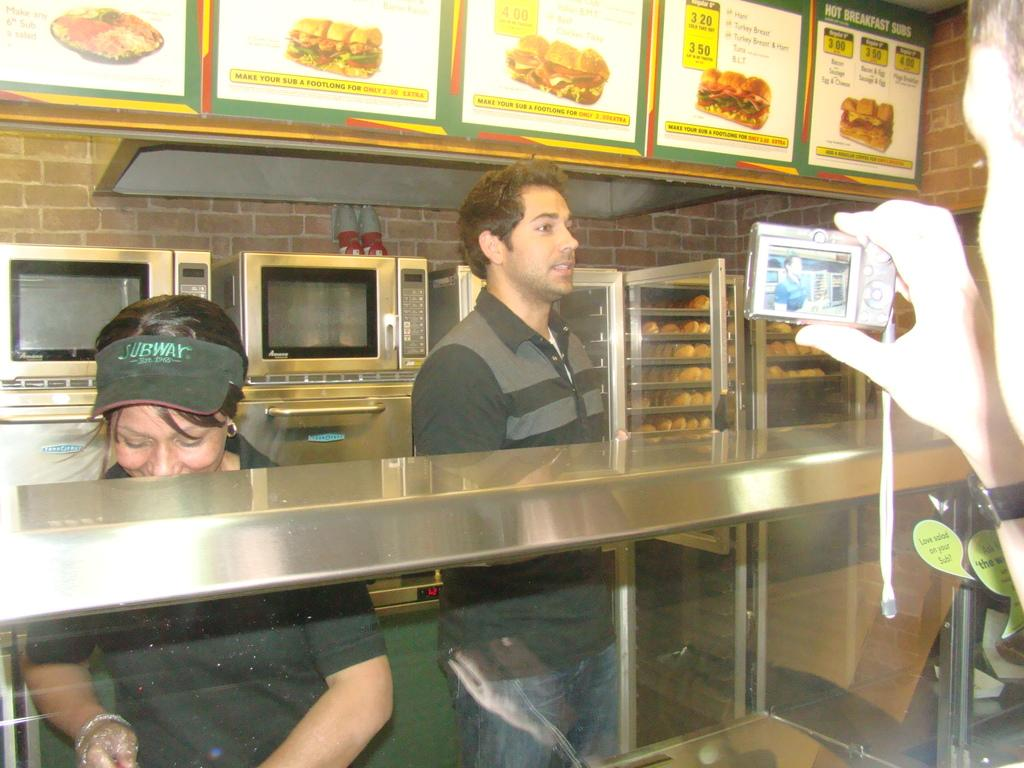<image>
Describe the image concisely. Two people are standing behind a stainless steel shelf, in a Subway restaurant. 